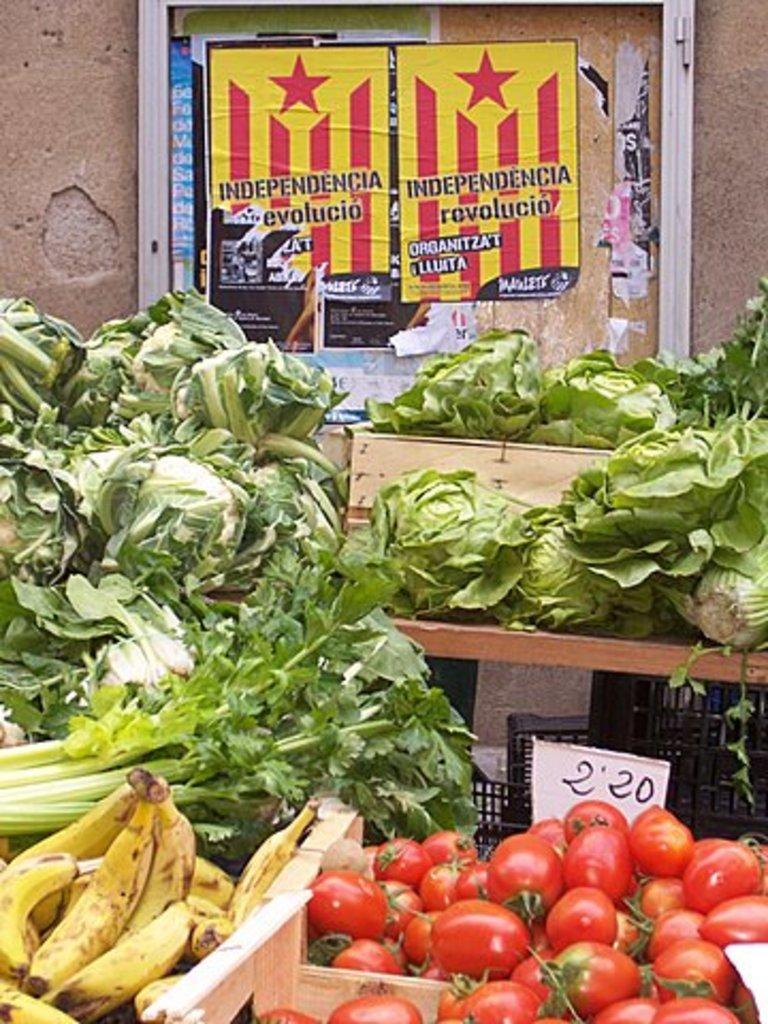Please provide a concise description of this image. In this image we can see so many vegetables are kept in different containers. Behind the vegetables one poster is present. 